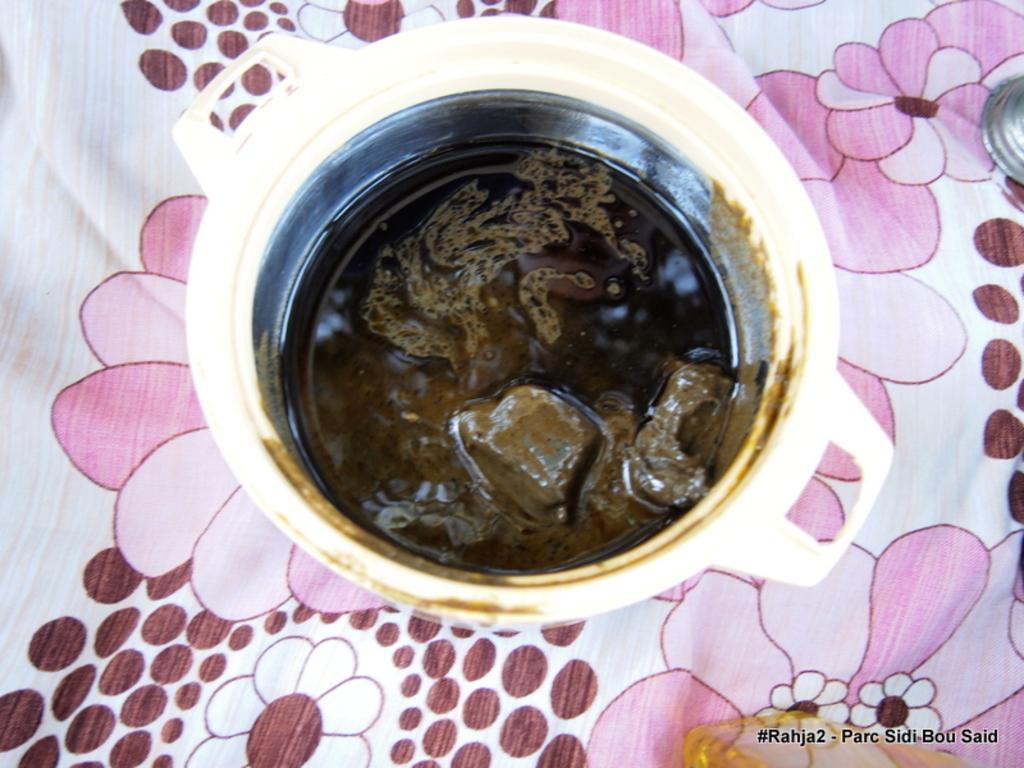What is in the bowl that is visible in the image? There is a dish in the bowl. Where is the bowl located in the image? The bowl is kept on a table. What is covering the table in the image? The table has a design cloth covering it. Where is the nearest store to buy toothpaste in the image? There is no information about a store or toothpaste in the image, so it cannot be determined from the image. 